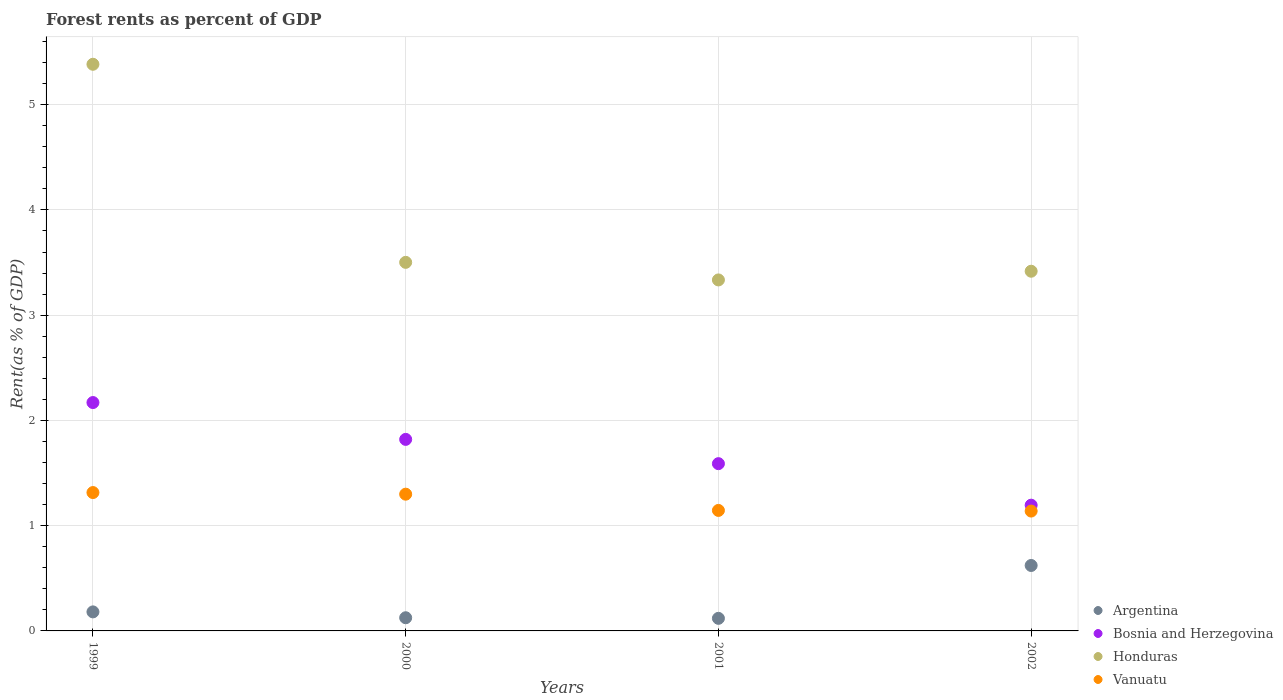How many different coloured dotlines are there?
Make the answer very short. 4. Is the number of dotlines equal to the number of legend labels?
Your answer should be compact. Yes. What is the forest rent in Argentina in 2002?
Provide a succinct answer. 0.62. Across all years, what is the maximum forest rent in Vanuatu?
Your response must be concise. 1.31. Across all years, what is the minimum forest rent in Vanuatu?
Make the answer very short. 1.14. What is the total forest rent in Vanuatu in the graph?
Your answer should be very brief. 4.9. What is the difference between the forest rent in Vanuatu in 1999 and that in 2002?
Ensure brevity in your answer.  0.18. What is the difference between the forest rent in Argentina in 1999 and the forest rent in Vanuatu in 2000?
Keep it short and to the point. -1.12. What is the average forest rent in Argentina per year?
Give a very brief answer. 0.26. In the year 2001, what is the difference between the forest rent in Vanuatu and forest rent in Argentina?
Offer a very short reply. 1.03. In how many years, is the forest rent in Vanuatu greater than 0.6000000000000001 %?
Give a very brief answer. 4. What is the ratio of the forest rent in Vanuatu in 2001 to that in 2002?
Ensure brevity in your answer.  1.01. Is the forest rent in Bosnia and Herzegovina in 2001 less than that in 2002?
Your response must be concise. No. What is the difference between the highest and the second highest forest rent in Vanuatu?
Ensure brevity in your answer.  0.02. What is the difference between the highest and the lowest forest rent in Honduras?
Offer a terse response. 2.05. In how many years, is the forest rent in Argentina greater than the average forest rent in Argentina taken over all years?
Offer a very short reply. 1. Is it the case that in every year, the sum of the forest rent in Vanuatu and forest rent in Bosnia and Herzegovina  is greater than the sum of forest rent in Honduras and forest rent in Argentina?
Your answer should be compact. Yes. Is the forest rent in Bosnia and Herzegovina strictly greater than the forest rent in Argentina over the years?
Your answer should be compact. Yes. How many years are there in the graph?
Offer a terse response. 4. What is the difference between two consecutive major ticks on the Y-axis?
Offer a terse response. 1. Are the values on the major ticks of Y-axis written in scientific E-notation?
Give a very brief answer. No. Does the graph contain grids?
Ensure brevity in your answer.  Yes. Where does the legend appear in the graph?
Your response must be concise. Bottom right. What is the title of the graph?
Provide a short and direct response. Forest rents as percent of GDP. Does "Mauritania" appear as one of the legend labels in the graph?
Provide a succinct answer. No. What is the label or title of the X-axis?
Offer a terse response. Years. What is the label or title of the Y-axis?
Offer a terse response. Rent(as % of GDP). What is the Rent(as % of GDP) in Argentina in 1999?
Make the answer very short. 0.18. What is the Rent(as % of GDP) in Bosnia and Herzegovina in 1999?
Offer a terse response. 2.17. What is the Rent(as % of GDP) of Honduras in 1999?
Offer a very short reply. 5.38. What is the Rent(as % of GDP) of Vanuatu in 1999?
Your answer should be very brief. 1.31. What is the Rent(as % of GDP) of Argentina in 2000?
Provide a short and direct response. 0.13. What is the Rent(as % of GDP) in Bosnia and Herzegovina in 2000?
Make the answer very short. 1.82. What is the Rent(as % of GDP) in Honduras in 2000?
Your answer should be very brief. 3.5. What is the Rent(as % of GDP) in Vanuatu in 2000?
Make the answer very short. 1.3. What is the Rent(as % of GDP) of Argentina in 2001?
Offer a very short reply. 0.12. What is the Rent(as % of GDP) in Bosnia and Herzegovina in 2001?
Offer a terse response. 1.59. What is the Rent(as % of GDP) of Honduras in 2001?
Offer a terse response. 3.33. What is the Rent(as % of GDP) in Vanuatu in 2001?
Keep it short and to the point. 1.14. What is the Rent(as % of GDP) in Argentina in 2002?
Provide a short and direct response. 0.62. What is the Rent(as % of GDP) in Bosnia and Herzegovina in 2002?
Provide a short and direct response. 1.19. What is the Rent(as % of GDP) in Honduras in 2002?
Provide a short and direct response. 3.42. What is the Rent(as % of GDP) in Vanuatu in 2002?
Offer a terse response. 1.14. Across all years, what is the maximum Rent(as % of GDP) of Argentina?
Your response must be concise. 0.62. Across all years, what is the maximum Rent(as % of GDP) of Bosnia and Herzegovina?
Offer a very short reply. 2.17. Across all years, what is the maximum Rent(as % of GDP) of Honduras?
Your response must be concise. 5.38. Across all years, what is the maximum Rent(as % of GDP) of Vanuatu?
Ensure brevity in your answer.  1.31. Across all years, what is the minimum Rent(as % of GDP) in Argentina?
Provide a succinct answer. 0.12. Across all years, what is the minimum Rent(as % of GDP) in Bosnia and Herzegovina?
Your response must be concise. 1.19. Across all years, what is the minimum Rent(as % of GDP) in Honduras?
Offer a very short reply. 3.33. Across all years, what is the minimum Rent(as % of GDP) in Vanuatu?
Your response must be concise. 1.14. What is the total Rent(as % of GDP) of Argentina in the graph?
Your answer should be compact. 1.05. What is the total Rent(as % of GDP) of Bosnia and Herzegovina in the graph?
Provide a succinct answer. 6.77. What is the total Rent(as % of GDP) in Honduras in the graph?
Provide a succinct answer. 15.64. What is the total Rent(as % of GDP) of Vanuatu in the graph?
Your answer should be compact. 4.9. What is the difference between the Rent(as % of GDP) in Argentina in 1999 and that in 2000?
Give a very brief answer. 0.06. What is the difference between the Rent(as % of GDP) of Bosnia and Herzegovina in 1999 and that in 2000?
Give a very brief answer. 0.35. What is the difference between the Rent(as % of GDP) in Honduras in 1999 and that in 2000?
Keep it short and to the point. 1.88. What is the difference between the Rent(as % of GDP) of Vanuatu in 1999 and that in 2000?
Your response must be concise. 0.02. What is the difference between the Rent(as % of GDP) in Argentina in 1999 and that in 2001?
Offer a terse response. 0.06. What is the difference between the Rent(as % of GDP) in Bosnia and Herzegovina in 1999 and that in 2001?
Offer a very short reply. 0.58. What is the difference between the Rent(as % of GDP) of Honduras in 1999 and that in 2001?
Make the answer very short. 2.05. What is the difference between the Rent(as % of GDP) of Vanuatu in 1999 and that in 2001?
Make the answer very short. 0.17. What is the difference between the Rent(as % of GDP) of Argentina in 1999 and that in 2002?
Your answer should be compact. -0.44. What is the difference between the Rent(as % of GDP) in Bosnia and Herzegovina in 1999 and that in 2002?
Your answer should be compact. 0.98. What is the difference between the Rent(as % of GDP) of Honduras in 1999 and that in 2002?
Offer a very short reply. 1.97. What is the difference between the Rent(as % of GDP) of Vanuatu in 1999 and that in 2002?
Keep it short and to the point. 0.18. What is the difference between the Rent(as % of GDP) of Argentina in 2000 and that in 2001?
Your answer should be very brief. 0.01. What is the difference between the Rent(as % of GDP) in Bosnia and Herzegovina in 2000 and that in 2001?
Give a very brief answer. 0.23. What is the difference between the Rent(as % of GDP) of Honduras in 2000 and that in 2001?
Provide a succinct answer. 0.17. What is the difference between the Rent(as % of GDP) in Vanuatu in 2000 and that in 2001?
Your answer should be compact. 0.15. What is the difference between the Rent(as % of GDP) of Argentina in 2000 and that in 2002?
Your response must be concise. -0.5. What is the difference between the Rent(as % of GDP) of Bosnia and Herzegovina in 2000 and that in 2002?
Give a very brief answer. 0.63. What is the difference between the Rent(as % of GDP) of Honduras in 2000 and that in 2002?
Provide a short and direct response. 0.08. What is the difference between the Rent(as % of GDP) of Vanuatu in 2000 and that in 2002?
Provide a succinct answer. 0.16. What is the difference between the Rent(as % of GDP) of Argentina in 2001 and that in 2002?
Make the answer very short. -0.5. What is the difference between the Rent(as % of GDP) of Bosnia and Herzegovina in 2001 and that in 2002?
Keep it short and to the point. 0.39. What is the difference between the Rent(as % of GDP) of Honduras in 2001 and that in 2002?
Make the answer very short. -0.08. What is the difference between the Rent(as % of GDP) of Vanuatu in 2001 and that in 2002?
Your answer should be very brief. 0.01. What is the difference between the Rent(as % of GDP) in Argentina in 1999 and the Rent(as % of GDP) in Bosnia and Herzegovina in 2000?
Provide a succinct answer. -1.64. What is the difference between the Rent(as % of GDP) of Argentina in 1999 and the Rent(as % of GDP) of Honduras in 2000?
Give a very brief answer. -3.32. What is the difference between the Rent(as % of GDP) of Argentina in 1999 and the Rent(as % of GDP) of Vanuatu in 2000?
Offer a very short reply. -1.12. What is the difference between the Rent(as % of GDP) in Bosnia and Herzegovina in 1999 and the Rent(as % of GDP) in Honduras in 2000?
Provide a succinct answer. -1.33. What is the difference between the Rent(as % of GDP) of Bosnia and Herzegovina in 1999 and the Rent(as % of GDP) of Vanuatu in 2000?
Your response must be concise. 0.87. What is the difference between the Rent(as % of GDP) in Honduras in 1999 and the Rent(as % of GDP) in Vanuatu in 2000?
Give a very brief answer. 4.08. What is the difference between the Rent(as % of GDP) of Argentina in 1999 and the Rent(as % of GDP) of Bosnia and Herzegovina in 2001?
Your answer should be very brief. -1.41. What is the difference between the Rent(as % of GDP) of Argentina in 1999 and the Rent(as % of GDP) of Honduras in 2001?
Your answer should be very brief. -3.15. What is the difference between the Rent(as % of GDP) of Argentina in 1999 and the Rent(as % of GDP) of Vanuatu in 2001?
Provide a short and direct response. -0.96. What is the difference between the Rent(as % of GDP) in Bosnia and Herzegovina in 1999 and the Rent(as % of GDP) in Honduras in 2001?
Give a very brief answer. -1.17. What is the difference between the Rent(as % of GDP) of Bosnia and Herzegovina in 1999 and the Rent(as % of GDP) of Vanuatu in 2001?
Make the answer very short. 1.02. What is the difference between the Rent(as % of GDP) in Honduras in 1999 and the Rent(as % of GDP) in Vanuatu in 2001?
Give a very brief answer. 4.24. What is the difference between the Rent(as % of GDP) of Argentina in 1999 and the Rent(as % of GDP) of Bosnia and Herzegovina in 2002?
Offer a very short reply. -1.01. What is the difference between the Rent(as % of GDP) of Argentina in 1999 and the Rent(as % of GDP) of Honduras in 2002?
Offer a terse response. -3.24. What is the difference between the Rent(as % of GDP) in Argentina in 1999 and the Rent(as % of GDP) in Vanuatu in 2002?
Provide a short and direct response. -0.96. What is the difference between the Rent(as % of GDP) of Bosnia and Herzegovina in 1999 and the Rent(as % of GDP) of Honduras in 2002?
Make the answer very short. -1.25. What is the difference between the Rent(as % of GDP) of Bosnia and Herzegovina in 1999 and the Rent(as % of GDP) of Vanuatu in 2002?
Offer a very short reply. 1.03. What is the difference between the Rent(as % of GDP) in Honduras in 1999 and the Rent(as % of GDP) in Vanuatu in 2002?
Provide a succinct answer. 4.25. What is the difference between the Rent(as % of GDP) of Argentina in 2000 and the Rent(as % of GDP) of Bosnia and Herzegovina in 2001?
Your response must be concise. -1.46. What is the difference between the Rent(as % of GDP) in Argentina in 2000 and the Rent(as % of GDP) in Honduras in 2001?
Give a very brief answer. -3.21. What is the difference between the Rent(as % of GDP) in Argentina in 2000 and the Rent(as % of GDP) in Vanuatu in 2001?
Offer a very short reply. -1.02. What is the difference between the Rent(as % of GDP) of Bosnia and Herzegovina in 2000 and the Rent(as % of GDP) of Honduras in 2001?
Keep it short and to the point. -1.51. What is the difference between the Rent(as % of GDP) in Bosnia and Herzegovina in 2000 and the Rent(as % of GDP) in Vanuatu in 2001?
Give a very brief answer. 0.67. What is the difference between the Rent(as % of GDP) of Honduras in 2000 and the Rent(as % of GDP) of Vanuatu in 2001?
Provide a short and direct response. 2.36. What is the difference between the Rent(as % of GDP) in Argentina in 2000 and the Rent(as % of GDP) in Bosnia and Herzegovina in 2002?
Make the answer very short. -1.07. What is the difference between the Rent(as % of GDP) of Argentina in 2000 and the Rent(as % of GDP) of Honduras in 2002?
Your answer should be compact. -3.29. What is the difference between the Rent(as % of GDP) in Argentina in 2000 and the Rent(as % of GDP) in Vanuatu in 2002?
Give a very brief answer. -1.01. What is the difference between the Rent(as % of GDP) of Bosnia and Herzegovina in 2000 and the Rent(as % of GDP) of Honduras in 2002?
Ensure brevity in your answer.  -1.6. What is the difference between the Rent(as % of GDP) of Bosnia and Herzegovina in 2000 and the Rent(as % of GDP) of Vanuatu in 2002?
Provide a succinct answer. 0.68. What is the difference between the Rent(as % of GDP) in Honduras in 2000 and the Rent(as % of GDP) in Vanuatu in 2002?
Provide a short and direct response. 2.36. What is the difference between the Rent(as % of GDP) in Argentina in 2001 and the Rent(as % of GDP) in Bosnia and Herzegovina in 2002?
Make the answer very short. -1.08. What is the difference between the Rent(as % of GDP) in Argentina in 2001 and the Rent(as % of GDP) in Honduras in 2002?
Offer a terse response. -3.3. What is the difference between the Rent(as % of GDP) in Argentina in 2001 and the Rent(as % of GDP) in Vanuatu in 2002?
Give a very brief answer. -1.02. What is the difference between the Rent(as % of GDP) in Bosnia and Herzegovina in 2001 and the Rent(as % of GDP) in Honduras in 2002?
Give a very brief answer. -1.83. What is the difference between the Rent(as % of GDP) of Bosnia and Herzegovina in 2001 and the Rent(as % of GDP) of Vanuatu in 2002?
Your response must be concise. 0.45. What is the difference between the Rent(as % of GDP) in Honduras in 2001 and the Rent(as % of GDP) in Vanuatu in 2002?
Your answer should be very brief. 2.2. What is the average Rent(as % of GDP) of Argentina per year?
Provide a short and direct response. 0.26. What is the average Rent(as % of GDP) of Bosnia and Herzegovina per year?
Offer a terse response. 1.69. What is the average Rent(as % of GDP) of Honduras per year?
Give a very brief answer. 3.91. What is the average Rent(as % of GDP) in Vanuatu per year?
Give a very brief answer. 1.22. In the year 1999, what is the difference between the Rent(as % of GDP) of Argentina and Rent(as % of GDP) of Bosnia and Herzegovina?
Ensure brevity in your answer.  -1.99. In the year 1999, what is the difference between the Rent(as % of GDP) of Argentina and Rent(as % of GDP) of Honduras?
Keep it short and to the point. -5.2. In the year 1999, what is the difference between the Rent(as % of GDP) in Argentina and Rent(as % of GDP) in Vanuatu?
Your response must be concise. -1.13. In the year 1999, what is the difference between the Rent(as % of GDP) in Bosnia and Herzegovina and Rent(as % of GDP) in Honduras?
Provide a succinct answer. -3.21. In the year 1999, what is the difference between the Rent(as % of GDP) of Bosnia and Herzegovina and Rent(as % of GDP) of Vanuatu?
Offer a very short reply. 0.86. In the year 1999, what is the difference between the Rent(as % of GDP) in Honduras and Rent(as % of GDP) in Vanuatu?
Your response must be concise. 4.07. In the year 2000, what is the difference between the Rent(as % of GDP) in Argentina and Rent(as % of GDP) in Bosnia and Herzegovina?
Offer a very short reply. -1.69. In the year 2000, what is the difference between the Rent(as % of GDP) of Argentina and Rent(as % of GDP) of Honduras?
Offer a terse response. -3.38. In the year 2000, what is the difference between the Rent(as % of GDP) of Argentina and Rent(as % of GDP) of Vanuatu?
Offer a very short reply. -1.17. In the year 2000, what is the difference between the Rent(as % of GDP) of Bosnia and Herzegovina and Rent(as % of GDP) of Honduras?
Offer a terse response. -1.68. In the year 2000, what is the difference between the Rent(as % of GDP) of Bosnia and Herzegovina and Rent(as % of GDP) of Vanuatu?
Provide a short and direct response. 0.52. In the year 2000, what is the difference between the Rent(as % of GDP) of Honduras and Rent(as % of GDP) of Vanuatu?
Ensure brevity in your answer.  2.2. In the year 2001, what is the difference between the Rent(as % of GDP) of Argentina and Rent(as % of GDP) of Bosnia and Herzegovina?
Offer a terse response. -1.47. In the year 2001, what is the difference between the Rent(as % of GDP) in Argentina and Rent(as % of GDP) in Honduras?
Provide a succinct answer. -3.22. In the year 2001, what is the difference between the Rent(as % of GDP) in Argentina and Rent(as % of GDP) in Vanuatu?
Provide a succinct answer. -1.03. In the year 2001, what is the difference between the Rent(as % of GDP) in Bosnia and Herzegovina and Rent(as % of GDP) in Honduras?
Provide a succinct answer. -1.75. In the year 2001, what is the difference between the Rent(as % of GDP) in Bosnia and Herzegovina and Rent(as % of GDP) in Vanuatu?
Provide a succinct answer. 0.44. In the year 2001, what is the difference between the Rent(as % of GDP) of Honduras and Rent(as % of GDP) of Vanuatu?
Offer a very short reply. 2.19. In the year 2002, what is the difference between the Rent(as % of GDP) of Argentina and Rent(as % of GDP) of Bosnia and Herzegovina?
Keep it short and to the point. -0.57. In the year 2002, what is the difference between the Rent(as % of GDP) in Argentina and Rent(as % of GDP) in Honduras?
Give a very brief answer. -2.8. In the year 2002, what is the difference between the Rent(as % of GDP) of Argentina and Rent(as % of GDP) of Vanuatu?
Your response must be concise. -0.52. In the year 2002, what is the difference between the Rent(as % of GDP) of Bosnia and Herzegovina and Rent(as % of GDP) of Honduras?
Keep it short and to the point. -2.22. In the year 2002, what is the difference between the Rent(as % of GDP) of Bosnia and Herzegovina and Rent(as % of GDP) of Vanuatu?
Your answer should be compact. 0.06. In the year 2002, what is the difference between the Rent(as % of GDP) in Honduras and Rent(as % of GDP) in Vanuatu?
Provide a succinct answer. 2.28. What is the ratio of the Rent(as % of GDP) of Argentina in 1999 to that in 2000?
Provide a short and direct response. 1.44. What is the ratio of the Rent(as % of GDP) in Bosnia and Herzegovina in 1999 to that in 2000?
Provide a short and direct response. 1.19. What is the ratio of the Rent(as % of GDP) in Honduras in 1999 to that in 2000?
Provide a short and direct response. 1.54. What is the ratio of the Rent(as % of GDP) in Vanuatu in 1999 to that in 2000?
Keep it short and to the point. 1.01. What is the ratio of the Rent(as % of GDP) of Argentina in 1999 to that in 2001?
Offer a terse response. 1.51. What is the ratio of the Rent(as % of GDP) of Bosnia and Herzegovina in 1999 to that in 2001?
Your answer should be very brief. 1.37. What is the ratio of the Rent(as % of GDP) of Honduras in 1999 to that in 2001?
Make the answer very short. 1.61. What is the ratio of the Rent(as % of GDP) in Vanuatu in 1999 to that in 2001?
Offer a terse response. 1.15. What is the ratio of the Rent(as % of GDP) in Argentina in 1999 to that in 2002?
Your response must be concise. 0.29. What is the ratio of the Rent(as % of GDP) of Bosnia and Herzegovina in 1999 to that in 2002?
Give a very brief answer. 1.82. What is the ratio of the Rent(as % of GDP) in Honduras in 1999 to that in 2002?
Provide a succinct answer. 1.58. What is the ratio of the Rent(as % of GDP) in Vanuatu in 1999 to that in 2002?
Your answer should be very brief. 1.15. What is the ratio of the Rent(as % of GDP) of Argentina in 2000 to that in 2001?
Provide a short and direct response. 1.05. What is the ratio of the Rent(as % of GDP) in Bosnia and Herzegovina in 2000 to that in 2001?
Make the answer very short. 1.15. What is the ratio of the Rent(as % of GDP) in Honduras in 2000 to that in 2001?
Your answer should be compact. 1.05. What is the ratio of the Rent(as % of GDP) of Vanuatu in 2000 to that in 2001?
Offer a very short reply. 1.13. What is the ratio of the Rent(as % of GDP) of Argentina in 2000 to that in 2002?
Offer a very short reply. 0.2. What is the ratio of the Rent(as % of GDP) of Bosnia and Herzegovina in 2000 to that in 2002?
Offer a very short reply. 1.52. What is the ratio of the Rent(as % of GDP) of Honduras in 2000 to that in 2002?
Offer a terse response. 1.02. What is the ratio of the Rent(as % of GDP) in Vanuatu in 2000 to that in 2002?
Offer a very short reply. 1.14. What is the ratio of the Rent(as % of GDP) of Argentina in 2001 to that in 2002?
Offer a very short reply. 0.19. What is the ratio of the Rent(as % of GDP) of Bosnia and Herzegovina in 2001 to that in 2002?
Ensure brevity in your answer.  1.33. What is the ratio of the Rent(as % of GDP) of Honduras in 2001 to that in 2002?
Ensure brevity in your answer.  0.98. What is the ratio of the Rent(as % of GDP) in Vanuatu in 2001 to that in 2002?
Provide a succinct answer. 1.01. What is the difference between the highest and the second highest Rent(as % of GDP) of Argentina?
Your answer should be compact. 0.44. What is the difference between the highest and the second highest Rent(as % of GDP) of Bosnia and Herzegovina?
Make the answer very short. 0.35. What is the difference between the highest and the second highest Rent(as % of GDP) in Honduras?
Offer a terse response. 1.88. What is the difference between the highest and the second highest Rent(as % of GDP) in Vanuatu?
Your answer should be very brief. 0.02. What is the difference between the highest and the lowest Rent(as % of GDP) in Argentina?
Make the answer very short. 0.5. What is the difference between the highest and the lowest Rent(as % of GDP) of Bosnia and Herzegovina?
Make the answer very short. 0.98. What is the difference between the highest and the lowest Rent(as % of GDP) of Honduras?
Your answer should be very brief. 2.05. What is the difference between the highest and the lowest Rent(as % of GDP) of Vanuatu?
Make the answer very short. 0.18. 